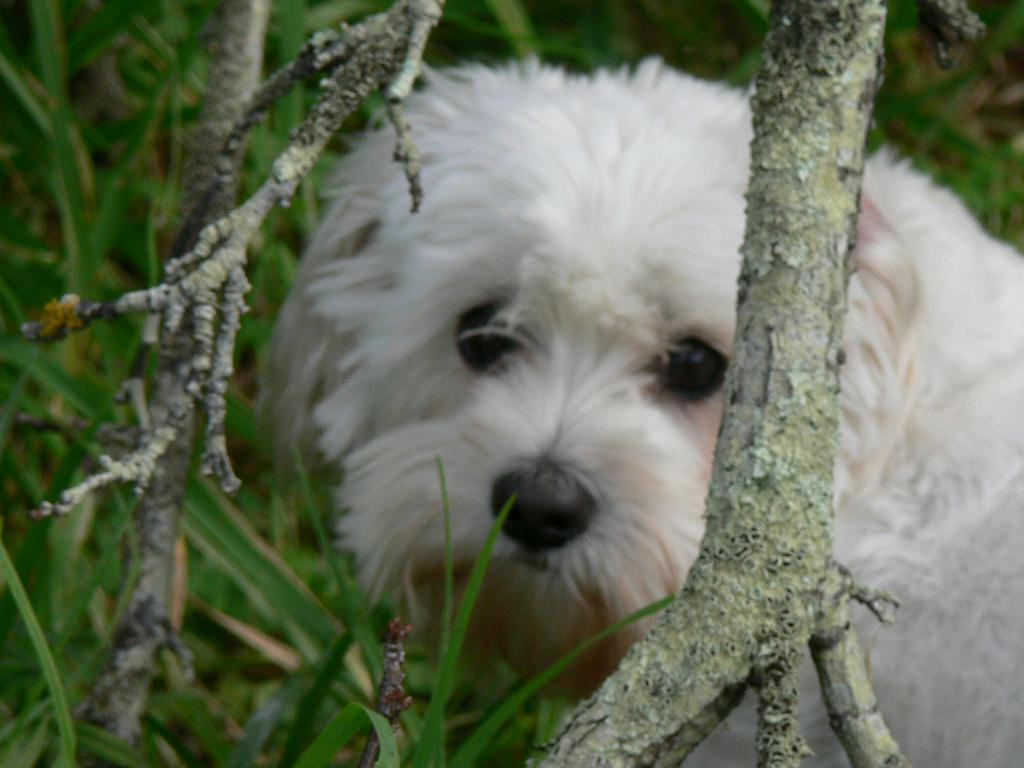What is the main subject of the image? There is a dog in the center of the image. Can you describe the appearance of the dog? The dog is white in color. What objects are in front of the dog? There are wooden objects in front of the dog. What can be seen in the background of the image? There is grass visible in the background of the image. What type of pear is the dog holding in its mouth in the image? There is no pear present in the image; the dog is not holding anything in its mouth. 